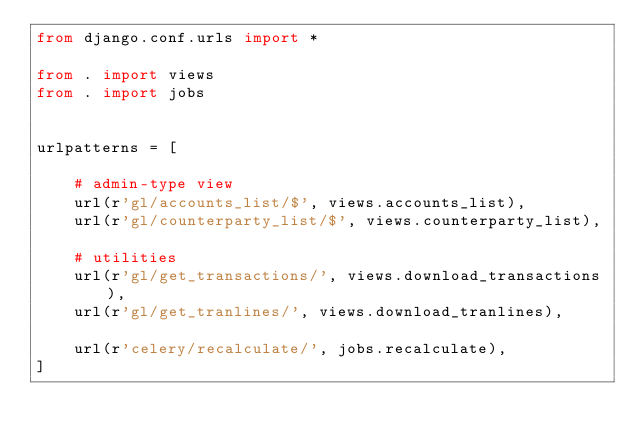Convert code to text. <code><loc_0><loc_0><loc_500><loc_500><_Python_>from django.conf.urls import *

from . import views
from . import jobs


urlpatterns = [

    # admin-type view
    url(r'gl/accounts_list/$', views.accounts_list),
    url(r'gl/counterparty_list/$', views.counterparty_list),

    # utilities
    url(r'gl/get_transactions/', views.download_transactions),
    url(r'gl/get_tranlines/', views.download_tranlines),

    url(r'celery/recalculate/', jobs.recalculate),
]
</code> 